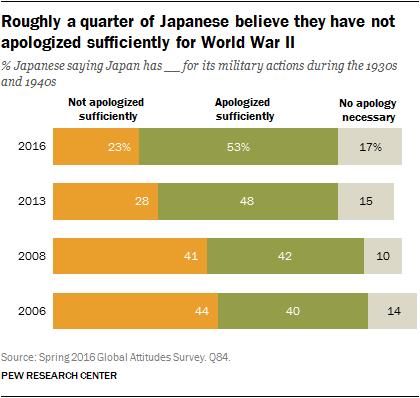Point out several critical features in this image. There are three colors represented in the bar. The average value of all green in the chart is 45.75. 